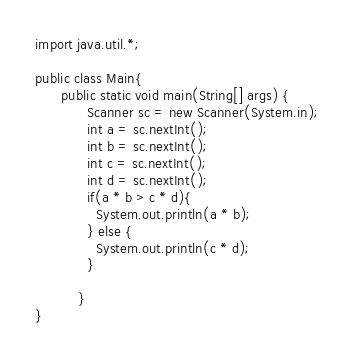<code> <loc_0><loc_0><loc_500><loc_500><_Java_>import java.util.*;

public class Main{
      public static void main(String[] args) {
            Scanner sc = new Scanner(System.in);
            int a = sc.nextInt();
            int b = sc.nextInt();
            int c = sc.nextInt();
            int d = sc.nextInt();
            if(a * b > c * d){
              System.out.println(a * b);
            } else {
              System.out.println(c * d);
            }
            
          }
}</code> 